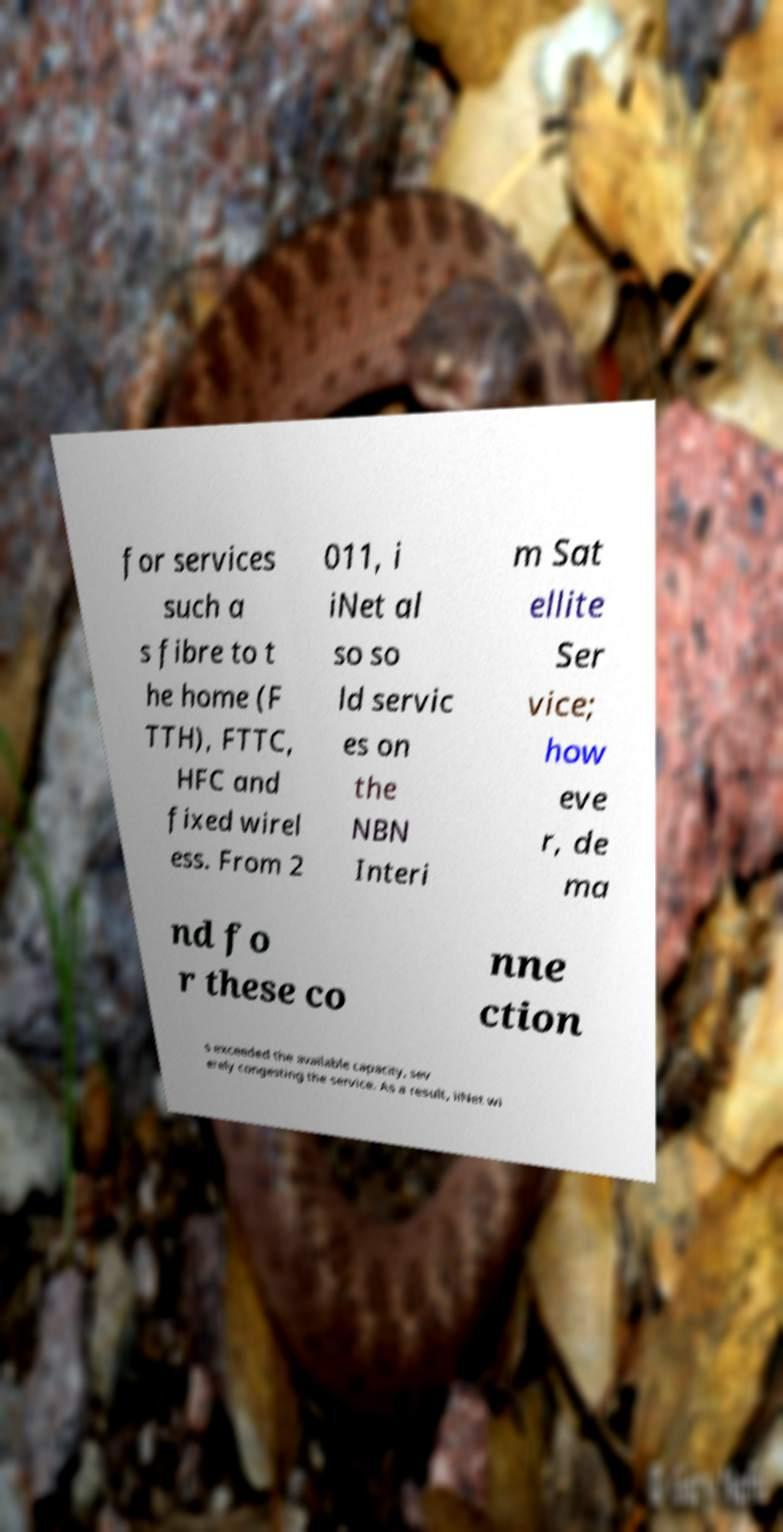I need the written content from this picture converted into text. Can you do that? for services such a s fibre to t he home (F TTH), FTTC, HFC and fixed wirel ess. From 2 011, i iNet al so so ld servic es on the NBN Interi m Sat ellite Ser vice; how eve r, de ma nd fo r these co nne ction s exceeded the available capacity, sev erely congesting the service. As a result, iiNet wi 